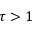Convert formula to latex. <formula><loc_0><loc_0><loc_500><loc_500>\tau > 1</formula> 